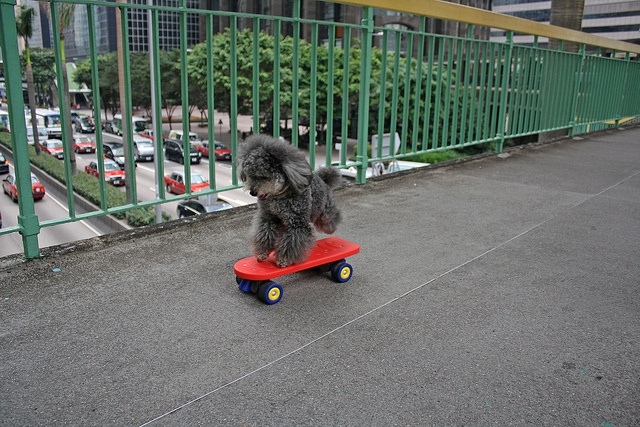Describe the objects in this image and their specific colors. I can see dog in teal, gray, black, and maroon tones, car in teal, gray, darkgray, and lavender tones, skateboard in teal, red, black, salmon, and brown tones, car in teal, lightgray, brown, darkgray, and gray tones, and car in teal, black, darkgray, gray, and lavender tones in this image. 